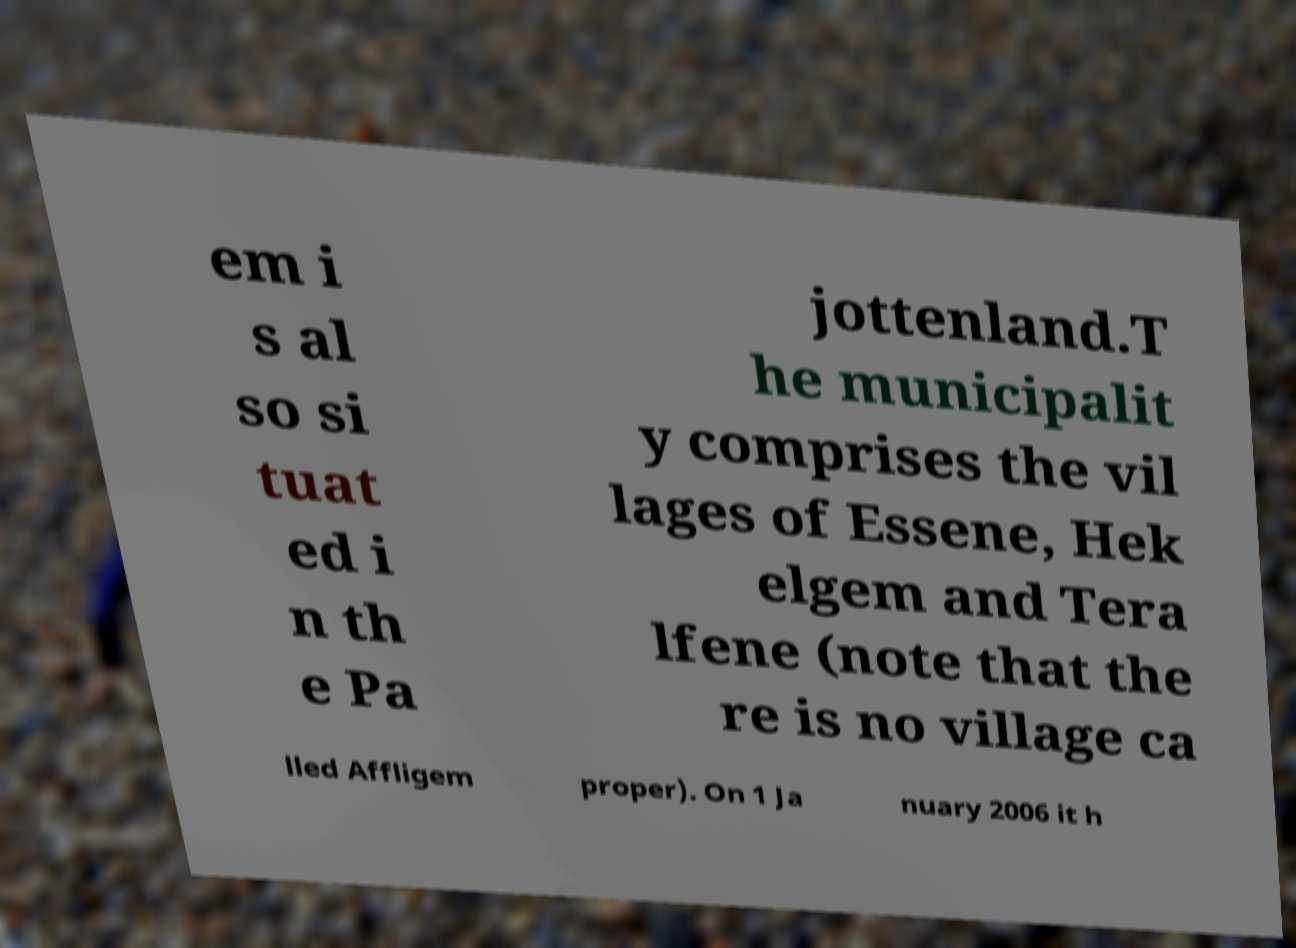Can you accurately transcribe the text from the provided image for me? em i s al so si tuat ed i n th e Pa jottenland.T he municipalit y comprises the vil lages of Essene, Hek elgem and Tera lfene (note that the re is no village ca lled Affligem proper). On 1 Ja nuary 2006 it h 